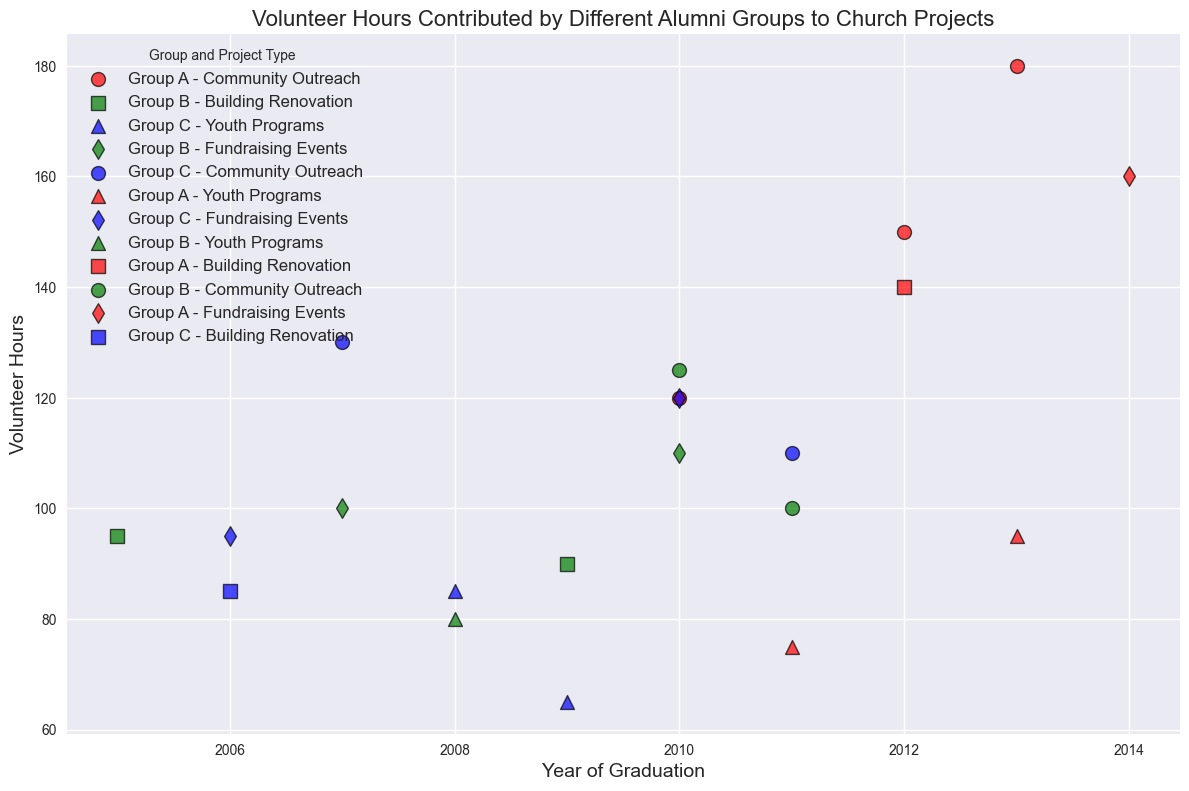What is the total volunteer hours contributed by Group A across all project types? To find the total volunteer hours for Group A, sum up all the hours associated with Group A's projects. These points are: 120, 150, 180, 140, 95, and 160 volunteer hours. Adding these gives 120 + 150 + 180 + 140 + 95 + 160 = 845.
Answer: 845 Which alumnus group has the highest volunteer hour contribution in a single project, and what project was it? By looking at the y-axis for the highest dot, we see that Group A contributed the highest volunteer hours in the Community Outreach project in 2013 with 180 hours.
Answer: Group A, Community Outreach How do the total volunteer hours for Community Outreach projects compare between Group A, Group B, and Group C? For Group A, the volunteer hours are 120, 150, 180, and 100. For Group B, volunteer hours are 125. For Group C, volunteer hours are 130 and 110. Summing these gives: Group A: 120+150+180+100 = 550, Group B: 125, Group C: 130+110 = 240.
Answer: Group A: 550, Group B: 125, Group C: 240 What is the average volunteer hours per project for Group C? Group C's total volunteer hours are from eight projects: 85, 130, 95, 120, 85, 65, 110, 100. The sum is 85 + 130 + 95 + 120 + 85 + 65 + 110 + 100 = 790. The average is 790/8 = 98.75.
Answer: 98.75 Between Group B's fundraising projects and Group C's fundraising projects, which group has more total volunteer hours and what is the difference? Group B's total volunteer hours for fundraising projects are 100 and 95, so 100 + 95 = 195. Group C's total is 120, so the difference is 195 - 120 = 75.
Answer: Group B, 75 What year did Group B contribute the most volunteer hours and how many hours were those? By examining the x-axis for Group B's highest dot, we see it was in the year 2010, contributing 125 hours for Community Outreach.
Answer: 2010, 125 hours Which project type has the highest average volunteer hours and what is that average? Calculate the average volunteer hours for each project type. Community Outreach: (120+150+180+100+125+130+110)/7 = 128.57, Building Renovation: (95+90+140+85)/4 = 102.5, Youth Programs: (85+75+80+65+95)/5 = 80, Fundraising Events: (110+95+120+160+100)/5 = 117. For Community Outreach, the average is the highest at 128.57.
Answer: Community Outreach, 128.57 What is the median volunteer hour contribution by Group A for all projects? Group A's volunteer hours are 120, 150, 180, 140, 95, 160. Ordering these: 95, 120, 140, 150, 160, 180. The median is (140+150)/2 = 145.
Answer: 145 How many volunteer hours did Group C contribute to Building Renovation projects in total? Group C's contributions to Building Renovation projects are 85 and 85. Summing these gives 85 + 85 = 170 volunteer hours.
Answer: 170 